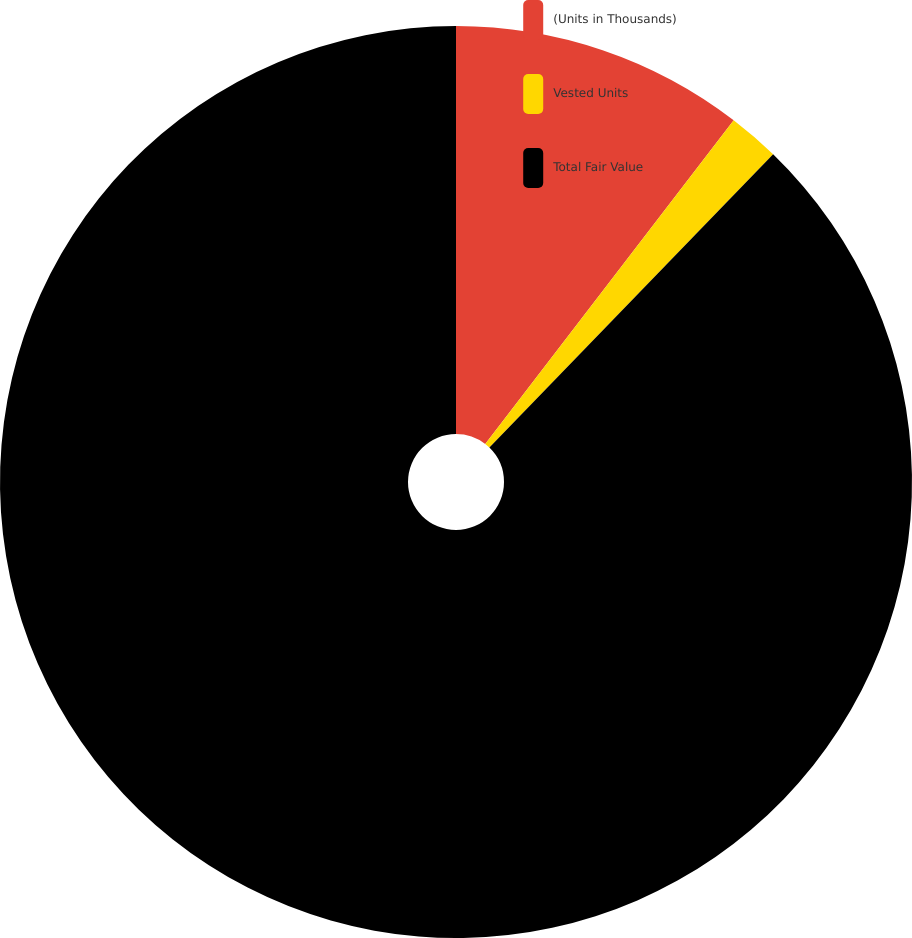Convert chart. <chart><loc_0><loc_0><loc_500><loc_500><pie_chart><fcel>(Units in Thousands)<fcel>Vested Units<fcel>Total Fair Value<nl><fcel>10.42%<fcel>1.82%<fcel>87.76%<nl></chart> 